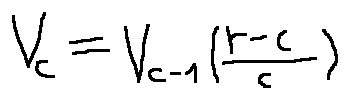<formula> <loc_0><loc_0><loc_500><loc_500>v _ { c } = v _ { c - 1 } ( \frac { r - c } { c } )</formula> 